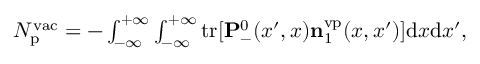<formula> <loc_0><loc_0><loc_500><loc_500>\begin{array} { r } { N _ { p } ^ { v a c } = - \int _ { - \infty } ^ { + \infty } \int _ { - \infty } ^ { + \infty } { t r } [ { P } _ { - } ^ { 0 } ( x ^ { \prime } , x ) { n } _ { 1 } ^ { v p } ( x , x ^ { \prime } ) ] { d } x { d } x ^ { \prime } , } \end{array}</formula> 